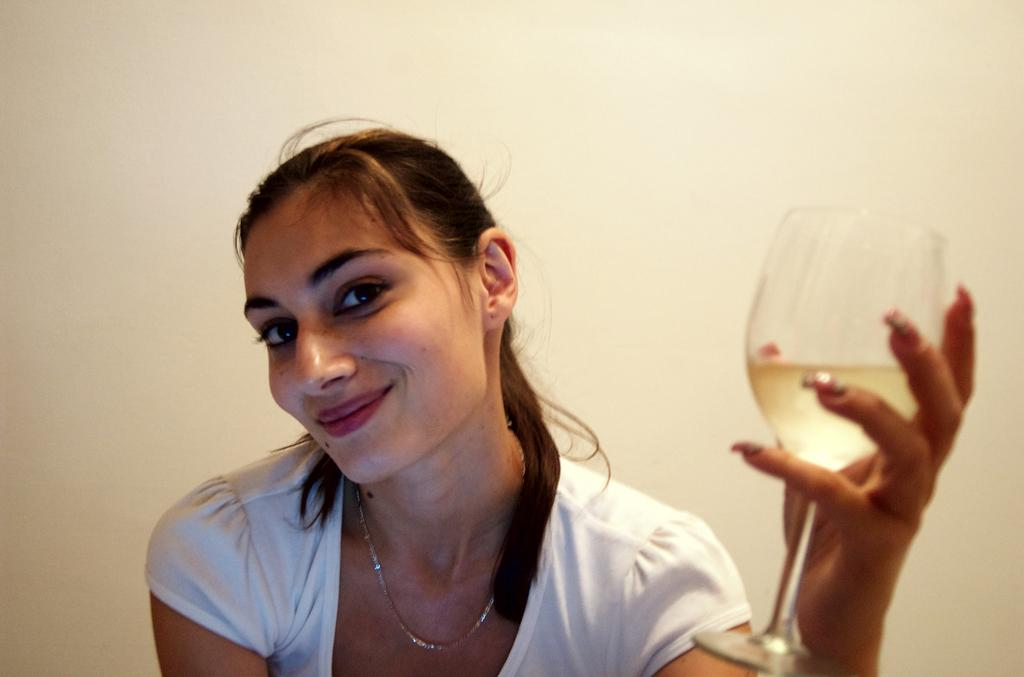Who is in the picture? There is a woman in the picture. What is the woman doing in the picture? The woman is sitting and smiling. What is the woman holding in the picture? The woman is holding a wine glass. What can be seen in the background of the picture? There is a wall in the background of the picture. What is the color of the wall in the background? The wall is off-cream color. What rhythm is the band playing in the background of the image? There is no band present in the image, so it is not possible to determine the rhythm they might be playing. 